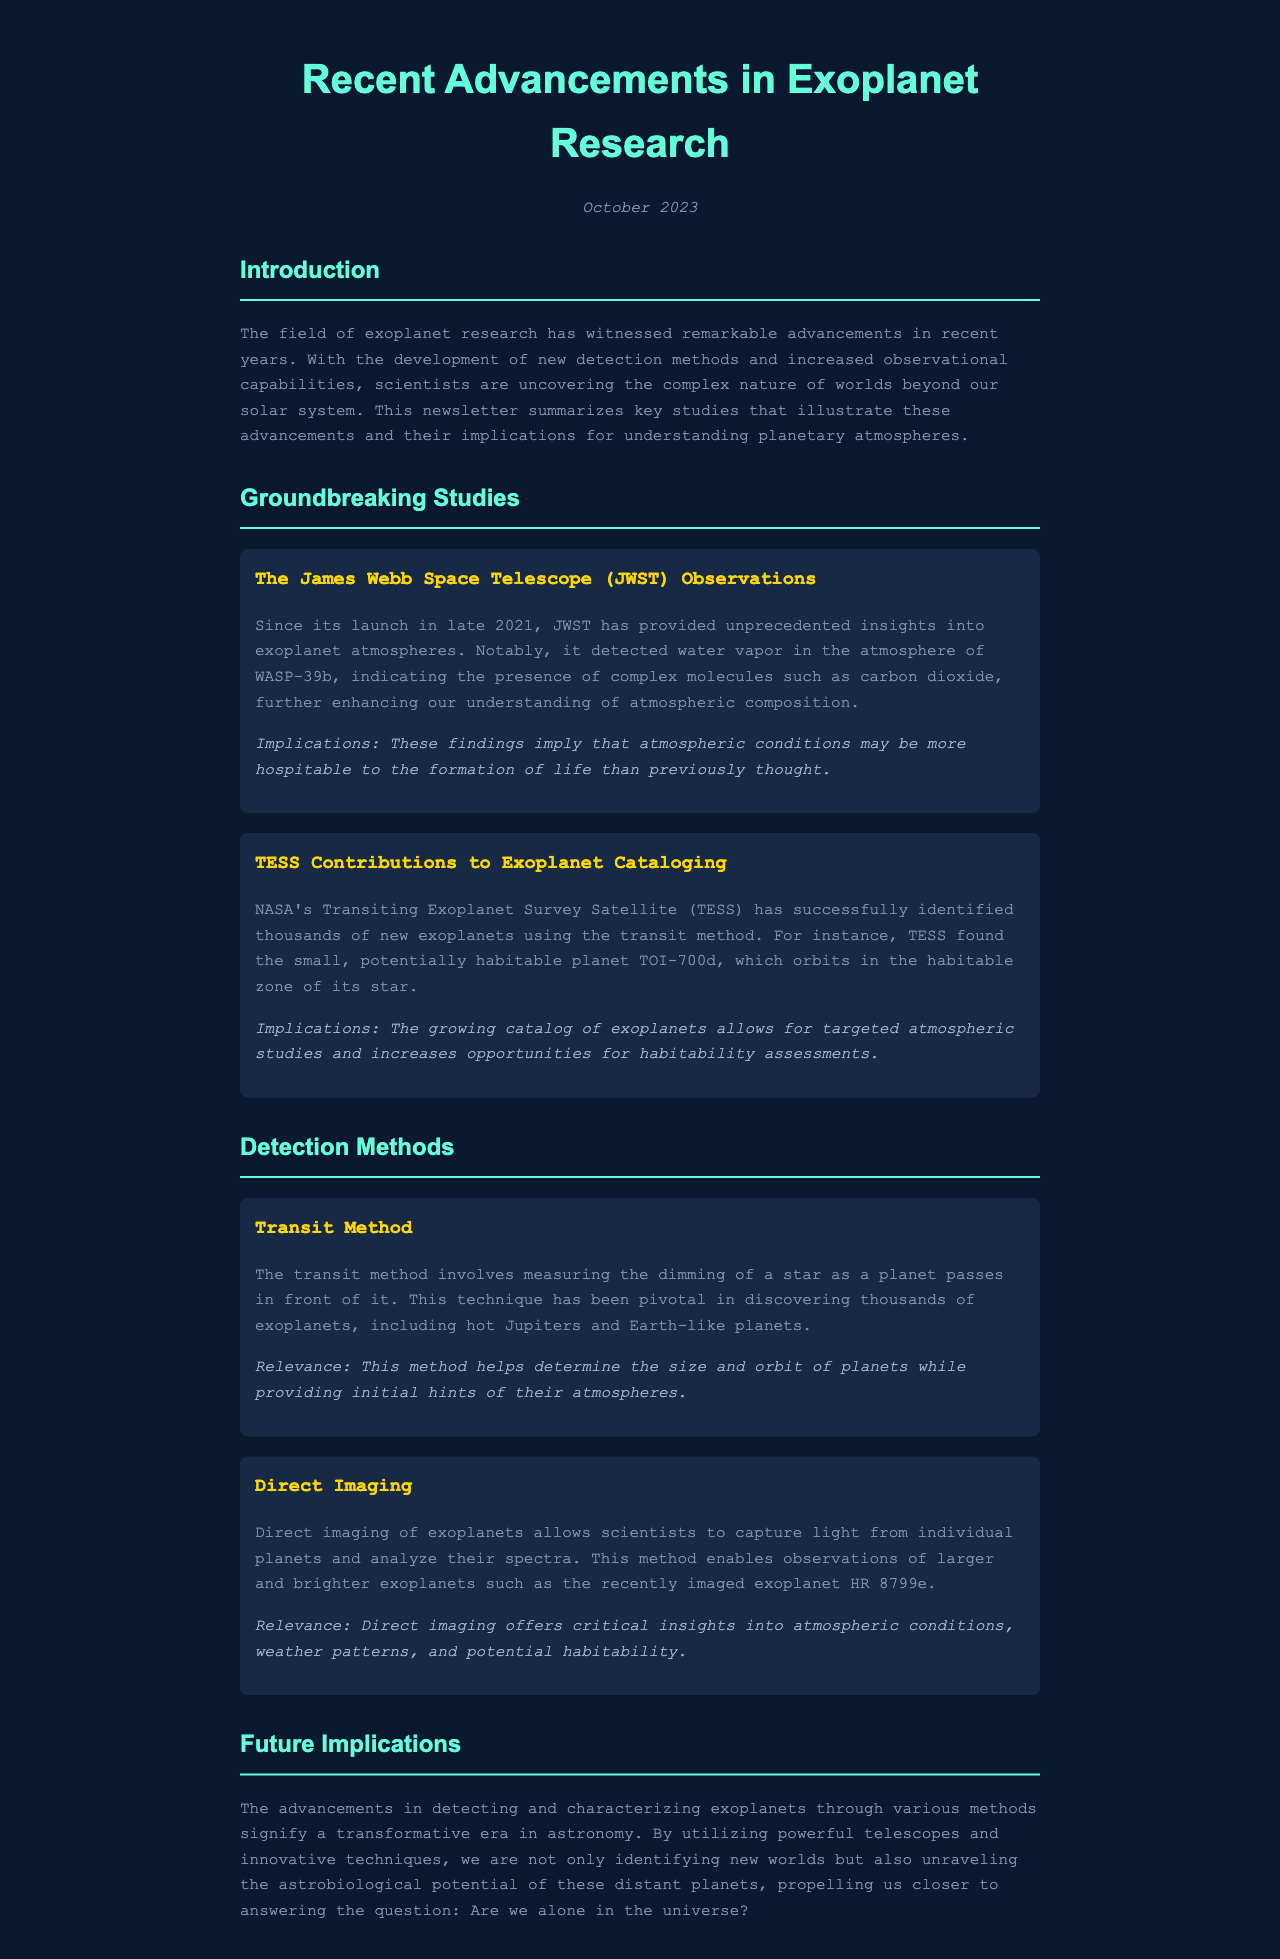What telescope provided unprecedented insights into exoplanet atmospheres? The document states that the James Webb Space Telescope has provided unprecedented insights into exoplanet atmospheres.
Answer: James Webb Space Telescope What key molecule was detected in the atmosphere of WASP-39b? The findings in the document mention that water vapor was detected in the atmosphere of WASP-39b.
Answer: Water vapor Which planet did TESS find that orbits in the habitable zone of its star? The document identifies TOI-700d as the planet found by TESS that orbits in the habitable zone of its star.
Answer: TOI-700d What year was the James Webb Space Telescope launched? According to the document, the James Webb Space Telescope was launched in late 2021.
Answer: 2021 What method involves measuring the dimming of a star? The document explains that the transit method involves measuring the dimming of a star as a planet passes in front of it.
Answer: Transit method Why is the growing catalog of exoplanets significant? The document implies that the growing catalog of exoplanets allows for targeted atmospheric studies and increases opportunities for habitability assessments.
Answer: Targeted atmospheric studies What exoplanet was recently imaged using direct imaging? The document mentions HR 8799e as the recently imaged exoplanet through direct imaging.
Answer: HR 8799e What overarching question does the document suggest we are getting closer to answering? The document posits that advancements in exoplanet research propel us closer to answering whether we are alone in the universe.
Answer: Are we alone in the universe? 